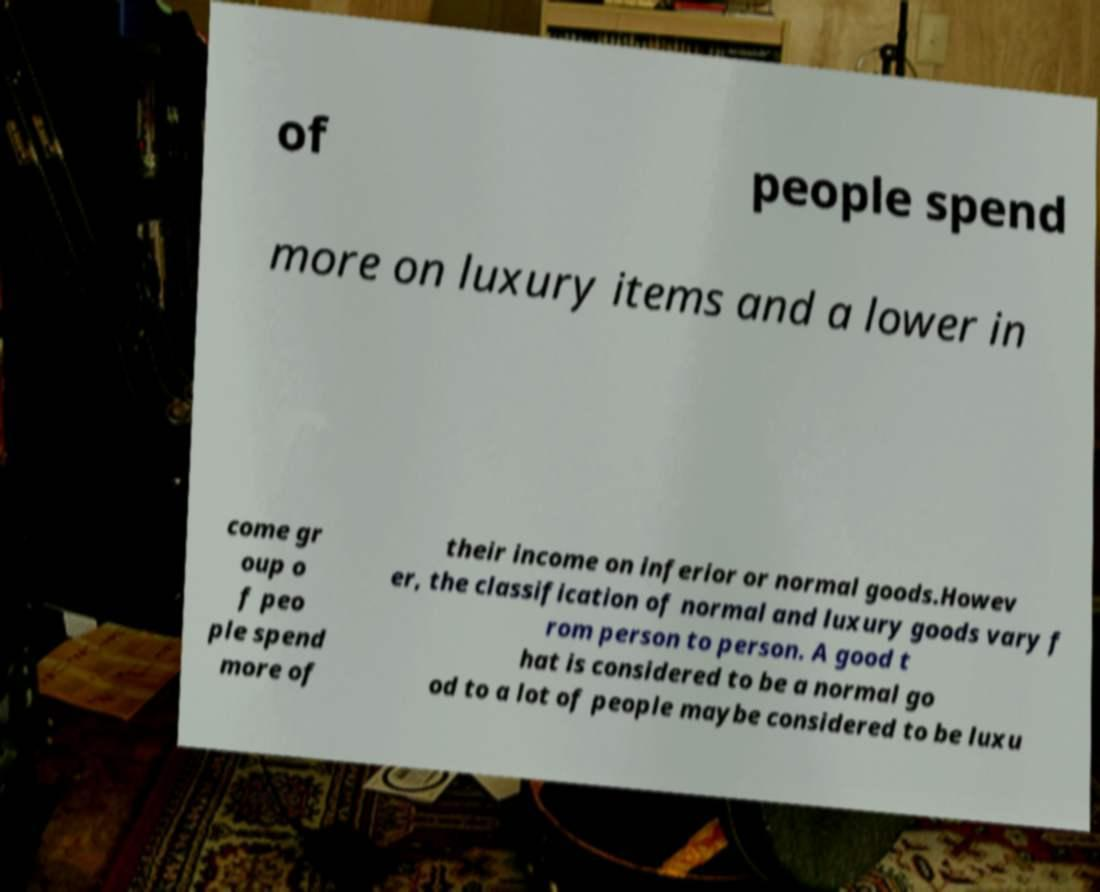Could you assist in decoding the text presented in this image and type it out clearly? of people spend more on luxury items and a lower in come gr oup o f peo ple spend more of their income on inferior or normal goods.Howev er, the classification of normal and luxury goods vary f rom person to person. A good t hat is considered to be a normal go od to a lot of people maybe considered to be luxu 